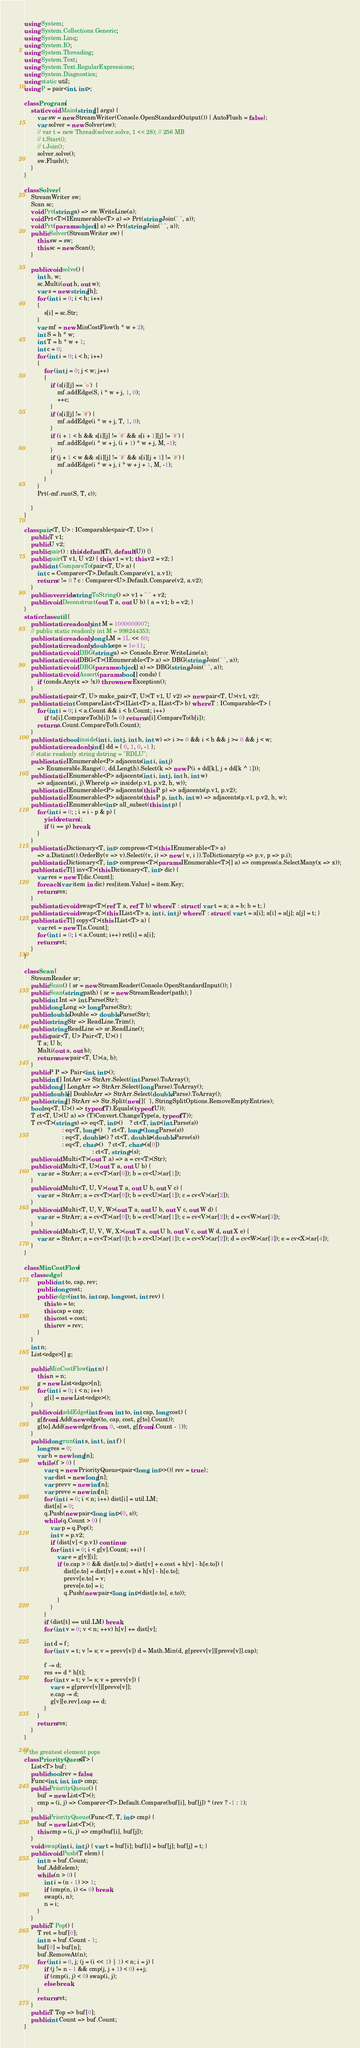Convert code to text. <code><loc_0><loc_0><loc_500><loc_500><_C#_>using System;
using System.Collections.Generic;
using System.Linq;
using System.IO;
using System.Threading;
using System.Text;
using System.Text.RegularExpressions;
using System.Diagnostics;
using static util;
using P = pair<int, int>;

class Program {
    static void Main(string[] args) {
        var sw = new StreamWriter(Console.OpenStandardOutput()) { AutoFlush = false };
        var solver = new Solver(sw);
        // var t = new Thread(solver.solve, 1 << 28); // 256 MB
        // t.Start();
        // t.Join();
        solver.solve();
        sw.Flush();
    }
}

class Solver {
    StreamWriter sw;
    Scan sc;
    void Prt(string a) => sw.WriteLine(a);
    void Prt<T>(IEnumerable<T> a) => Prt(string.Join(" ", a));
    void Prt(params object[] a) => Prt(string.Join(" ", a));
    public Solver(StreamWriter sw) {
        this.sw = sw;
        this.sc = new Scan();
    }

    public void solve() {
        int h, w;
        sc.Multi(out h, out w);
        var s = new string[h];
        for (int i = 0; i < h; i++)
        {
            s[i] = sc.Str;
        }
        var mf = new MinCostFlow(h * w + 2);
        int S = h * w;
        int T = h * w + 1;
        int c = 0;
        for (int i = 0; i < h; i++)
        {
            for (int j = 0; j < w; j++)
            {
                if (s[i][j] == 'o')  {
                    mf.addEdge(S, i * w + j, 1, 0);
                    ++c;
                }
                if (s[i][j] != '#') {
                    mf.addEdge(i * w + j, T, 1, 0);
                }
                if (i + 1 < h && s[i][j] != '#' && s[i + 1][j] != '#') {
                    mf.addEdge(i * w + j, (i + 1) * w + j, M, -1);
                }
                if (j + 1 < w && s[i][j] != '#' && s[i][j + 1] != '#') {
                    mf.addEdge(i * w + j, i * w + j + 1, M, -1);
                }
            }
        }
        Prt(-mf.run(S, T, c));

    }
}

class pair<T, U> : IComparable<pair<T, U>> {
    public T v1;
    public U v2;
    public pair() : this(default(T), default(U)) {}
    public pair(T v1, U v2) { this.v1 = v1; this.v2 = v2; }
    public int CompareTo(pair<T, U> a) {
        int c = Comparer<T>.Default.Compare(v1, a.v1);
        return c != 0 ? c : Comparer<U>.Default.Compare(v2, a.v2);
    }
    public override string ToString() => v1 + " " + v2;
    public void Deconstruct(out T a, out U b) { a = v1; b = v2; }
}
static class util {
    public static readonly int M = 1000000007;
    // public static readonly int M = 998244353;
    public static readonly long LM = 1L << 60;
    public static readonly double eps = 1e-11;
    public static void DBG(string a) => Console.Error.WriteLine(a);
    public static void DBG<T>(IEnumerable<T> a) => DBG(string.Join(" ", a));
    public static void DBG(params object[] a) => DBG(string.Join(" ", a));
    public static void Assert(params bool[] conds) {
        if (conds.Any(x => !x)) throw new Exception();
    }
    public static pair<T, U> make_pair<T, U>(T v1, U v2) => new pair<T, U>(v1, v2);
    public static int CompareList<T>(IList<T> a, IList<T> b) where T : IComparable<T> {
        for (int i = 0; i < a.Count && i < b.Count; i++)
            if (a[i].CompareTo(b[i]) != 0) return a[i].CompareTo(b[i]);
        return a.Count.CompareTo(b.Count);
    }
    public static bool inside(int i, int j, int h, int w) => i >= 0 && i < h && j >= 0 && j < w;
    public static readonly int[] dd = { 0, 1, 0, -1 };
    // static readonly string dstring = "RDLU";
    public static IEnumerable<P> adjacents(int i, int j)
        => Enumerable.Range(0, dd.Length).Select(k => new P(i + dd[k], j + dd[k ^ 1]));
    public static IEnumerable<P> adjacents(int i, int j, int h, int w)
        => adjacents(i, j).Where(p => inside(p.v1, p.v2, h, w));
    public static IEnumerable<P> adjacents(this P p) => adjacents(p.v1, p.v2);
    public static IEnumerable<P> adjacents(this P p, int h, int w) => adjacents(p.v1, p.v2, h, w);
    public static IEnumerable<int> all_subset(this int p) {
        for (int i = 0; ; i = i - p & p) {
            yield return i;
            if (i == p) break;
        }
    }
    public static Dictionary<T, int> compress<T>(this IEnumerable<T> a)
        => a.Distinct().OrderBy(v => v).Select((v, i) => new { v, i }).ToDictionary(p => p.v, p => p.i);
    public static Dictionary<T, int> compress<T>(params IEnumerable<T>[] a) => compress(a.SelectMany(x => x));
    public static T[] inv<T>(this Dictionary<T, int> dic) {
        var res = new T[dic.Count];
        foreach (var item in dic) res[item.Value] = item.Key;
        return res;
    }
    public static void swap<T>(ref T a, ref T b) where T : struct { var t = a; a = b; b = t; }
    public static void swap<T>(this IList<T> a, int i, int j) where T : struct { var t = a[i]; a[i] = a[j]; a[j] = t; }
    public static T[] copy<T>(this IList<T> a) {
        var ret = new T[a.Count];
        for (int i = 0; i < a.Count; i++) ret[i] = a[i];
        return ret;
    }
}

class Scan {
    StreamReader sr;
    public Scan() { sr = new StreamReader(Console.OpenStandardInput()); }
    public Scan(string path) { sr = new StreamReader(path); }
    public int Int => int.Parse(Str);
    public long Long => long.Parse(Str);
    public double Double => double.Parse(Str);
    public string Str => ReadLine.Trim();
    public string ReadLine => sr.ReadLine();
    public pair<T, U> Pair<T, U>() {
        T a; U b;
        Multi(out a, out b);
        return new pair<T, U>(a, b);
    }
    public P P => Pair<int, int>();
    public int[] IntArr => StrArr.Select(int.Parse).ToArray();
    public long[] LongArr => StrArr.Select(long.Parse).ToArray();
    public double[] DoubleArr => StrArr.Select(double.Parse).ToArray();
    public string[] StrArr => Str.Split(new[]{' '}, StringSplitOptions.RemoveEmptyEntries);
    bool eq<T, U>() => typeof(T).Equals(typeof(U));
    T ct<T, U>(U a) => (T)Convert.ChangeType(a, typeof(T));
    T cv<T>(string s) => eq<T, int>()    ? ct<T, int>(int.Parse(s))
                       : eq<T, long>()   ? ct<T, long>(long.Parse(s))
                       : eq<T, double>() ? ct<T, double>(double.Parse(s))
                       : eq<T, char>()   ? ct<T, char>(s[0])
                                         : ct<T, string>(s);
    public void Multi<T>(out T a) => a = cv<T>(Str);
    public void Multi<T, U>(out T a, out U b) {
        var ar = StrArr; a = cv<T>(ar[0]); b = cv<U>(ar[1]);
    }
    public void Multi<T, U, V>(out T a, out U b, out V c) {
        var ar = StrArr; a = cv<T>(ar[0]); b = cv<U>(ar[1]); c = cv<V>(ar[2]);
    }
    public void Multi<T, U, V, W>(out T a, out U b, out V c, out W d) {
        var ar = StrArr; a = cv<T>(ar[0]); b = cv<U>(ar[1]); c = cv<V>(ar[2]); d = cv<W>(ar[3]);
    }
    public void Multi<T, U, V, W, X>(out T a, out U b, out V c, out W d, out X e) {
        var ar = StrArr; a = cv<T>(ar[0]); b = cv<U>(ar[1]); c = cv<V>(ar[2]); d = cv<W>(ar[3]); e = cv<X>(ar[4]);
    }
}

class MinCostFlow {
    class edge {
        public int to, cap, rev;
        public long cost;
        public edge(int to, int cap, long cost, int rev) {
            this.to = to;
            this.cap = cap;
            this.cost = cost;
            this.rev = rev;
        }
    }
    int n;
    List<edge>[] g;

    public MinCostFlow(int n) {
        this.n = n;
        g = new List<edge>[n];
        for (int i = 0; i < n; i++)
            g[i] = new List<edge>();
    }
    public void addEdge(int from, int to, int cap, long cost) {
        g[from].Add(new edge(to, cap, cost, g[to].Count));
        g[to].Add(new edge(from, 0, -cost, g[from].Count - 1));
    }
    public long run(int s, int t, int f) {
        long res = 0;
        var h = new long[n];
        while (f > 0) {
            var q = new PriorityQueue<pair<long, int>>(){ rev = true };
            var dist = new long[n];
            var prevv = new int[n];
            var preve = new int[n];
            for (int i = 0; i < n; i++) dist[i] = util.LM;
            dist[s] = 0;
            q.Push(new pair<long, int>(0, s));
            while (q.Count > 0) {
                var p = q.Pop();
                int v = p.v2;
                if (dist[v] < p.v1) continue;
                for (int i = 0; i < g[v].Count; ++i) {
                    var e = g[v][i];
                    if (e.cap > 0 && dist[e.to] > dist[v] + e.cost + h[v] - h[e.to]) {
                        dist[e.to] = dist[v] + e.cost + h[v] - h[e.to];
                        prevv[e.to] = v;
                        preve[e.to] = i;
                        q.Push(new pair<long, int>(dist[e.to], e.to));
                    }
                }
            }
            if (dist[t] == util.LM) break;
            for (int v = 0; v < n; ++v) h[v] += dist[v];

            int d = f;
            for (int v = t; v != s; v = prevv[v]) d = Math.Min(d, g[prevv[v]][preve[v]].cap);

            f -= d;
            res += d * h[t];
            for (int v = t; v != s; v = prevv[v]) {
                var e = g[prevv[v]][preve[v]];
                e.cap -= d;
                g[v][e.rev].cap += d;
            }
        }
        return res;
    }
}

// the greatest element pops
class PriorityQueue<T> {
    List<T> buf;
    public bool rev = false;
    Func<int, int, int> cmp;
    public PriorityQueue() {
        buf = new List<T>();
        cmp = (i, j) => Comparer<T>.Default.Compare(buf[i], buf[j]) * (rev ? -1 : 1);
    }
    public PriorityQueue(Func<T, T, int> cmp) {
        buf = new List<T>();
        this.cmp = (i, j) => cmp(buf[i], buf[j]);
    }
    void swap(int i, int j) { var t = buf[i]; buf[i] = buf[j]; buf[j] = t; }
    public void Push(T elem) {
        int n = buf.Count;
        buf.Add(elem);
        while (n > 0) {
            int i = (n - 1) >> 1;
            if (cmp(n, i) <= 0) break;
            swap(i, n);
            n = i;
        }
    }
    public T Pop() {
        T ret = buf[0];
        int n = buf.Count - 1;
        buf[0] = buf[n];
        buf.RemoveAt(n);
        for (int i = 0, j; (j = (i << 1) | 1) < n; i = j) {
            if (j != n - 1 && cmp(j, j + 1) < 0) ++j;
            if (cmp(i, j) < 0) swap(i, j);
            else break;
        }
        return ret;
    }
    public T Top => buf[0];
    public int Count => buf.Count;
}
</code> 